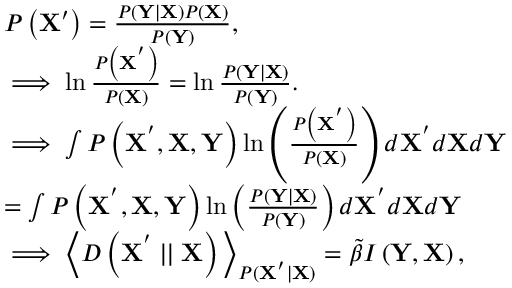<formula> <loc_0><loc_0><loc_500><loc_500>\begin{array} { r l } & { P \left ( X ^ { \prime } \right ) = \frac { P \left ( Y | X \right ) P \left ( X \right ) } { P \left ( Y \right ) } , } \\ & { \implies \ln \frac { P \left ( X ^ { ^ { \prime } } \right ) } { P \left ( X \right ) } = \ln \frac { P \left ( Y | X \right ) } { P \left ( Y \right ) } . } \\ & { \implies \int P \left ( X ^ { ^ { \prime } } , X , Y \right ) \ln \left ( \frac { P \left ( X ^ { ^ { \prime } } \right ) } { P \left ( X \right ) } \right ) d X ^ { ^ { \prime } } d X d Y } \\ & { = \int P \left ( X ^ { ^ { \prime } } , X , Y \right ) \ln \left ( \frac { P \left ( Y | X \right ) } { P \left ( Y \right ) } \right ) d X ^ { ^ { \prime } } d X d Y } \\ & { \implies \left \langle D \left ( X ^ { ^ { \prime } } | | X \right ) \right \rangle _ { P ( X ^ { ^ { \prime } } | X ) } = \tilde { \beta } I \left ( Y , X \right ) , } \end{array}</formula> 